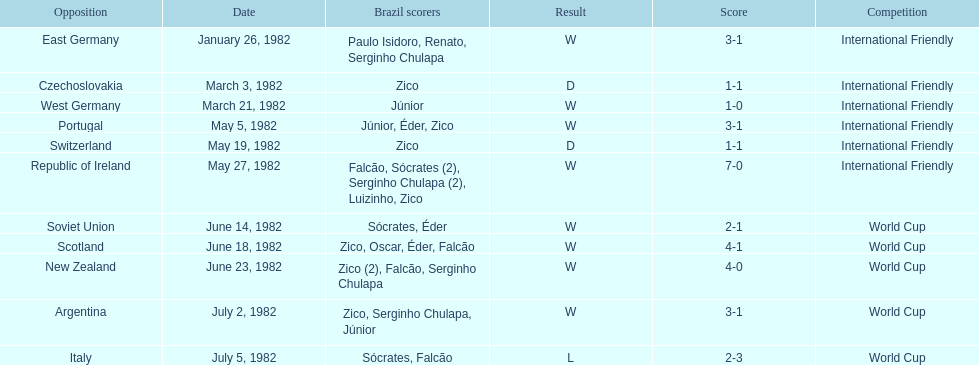Who was this team's next opponent after facing the soviet union on june 14? Scotland. 